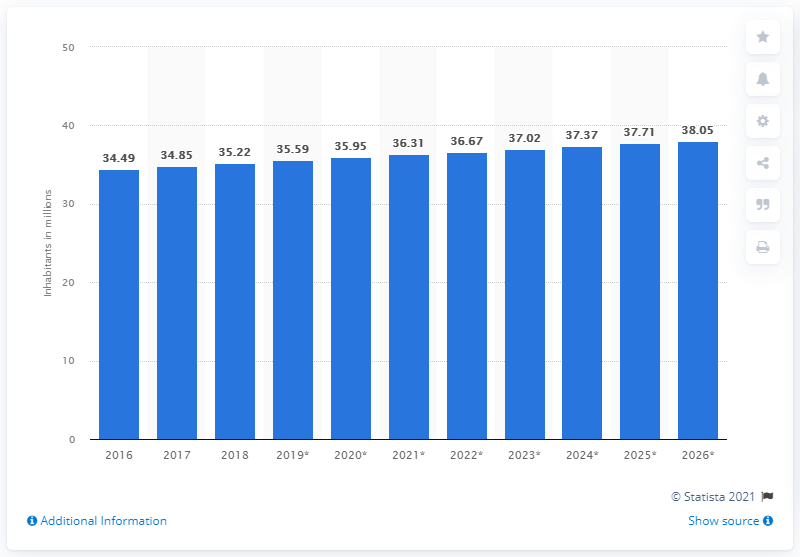Draw attention to some important aspects in this diagram. In 2018, the population of Morocco was 35.22 million, according to recent estimates. 